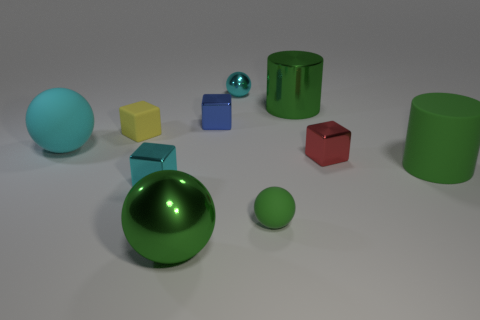There is a tiny matte ball; is its color the same as the large cylinder behind the yellow cube?
Offer a very short reply. Yes. What number of other things are the same size as the blue block?
Offer a very short reply. 5. There is a cube that is the same color as the small metal ball; what is its size?
Your answer should be very brief. Small. How many blocks are either shiny objects or cyan things?
Keep it short and to the point. 3. There is a tiny matte thing behind the rubber cylinder; is its shape the same as the small red metal object?
Keep it short and to the point. Yes. Are there more large green shiny things that are on the left side of the small red cube than big purple matte cylinders?
Your response must be concise. Yes. What color is the other matte block that is the same size as the red block?
Ensure brevity in your answer.  Yellow. How many objects are cyan things that are on the right side of the tiny yellow thing or large matte objects?
Offer a terse response. 4. What is the shape of the big thing that is the same color as the tiny metal sphere?
Ensure brevity in your answer.  Sphere. What material is the object behind the large object behind the large rubber ball?
Make the answer very short. Metal. 